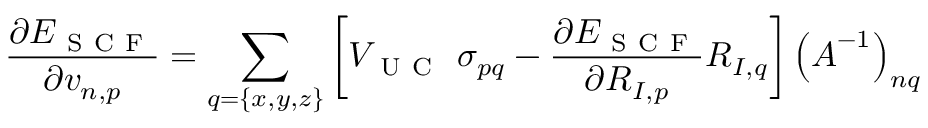Convert formula to latex. <formula><loc_0><loc_0><loc_500><loc_500>\frac { \partial E _ { S C F } } { \partial v _ { n , p } } = \sum _ { q = \{ x , y , z \} } \left [ V _ { U C } \sigma _ { p q } - \frac { \partial E _ { S C F } } { \partial R _ { I , p } } R _ { I , q } \right ] \left ( A ^ { - 1 } \right ) _ { n q }</formula> 